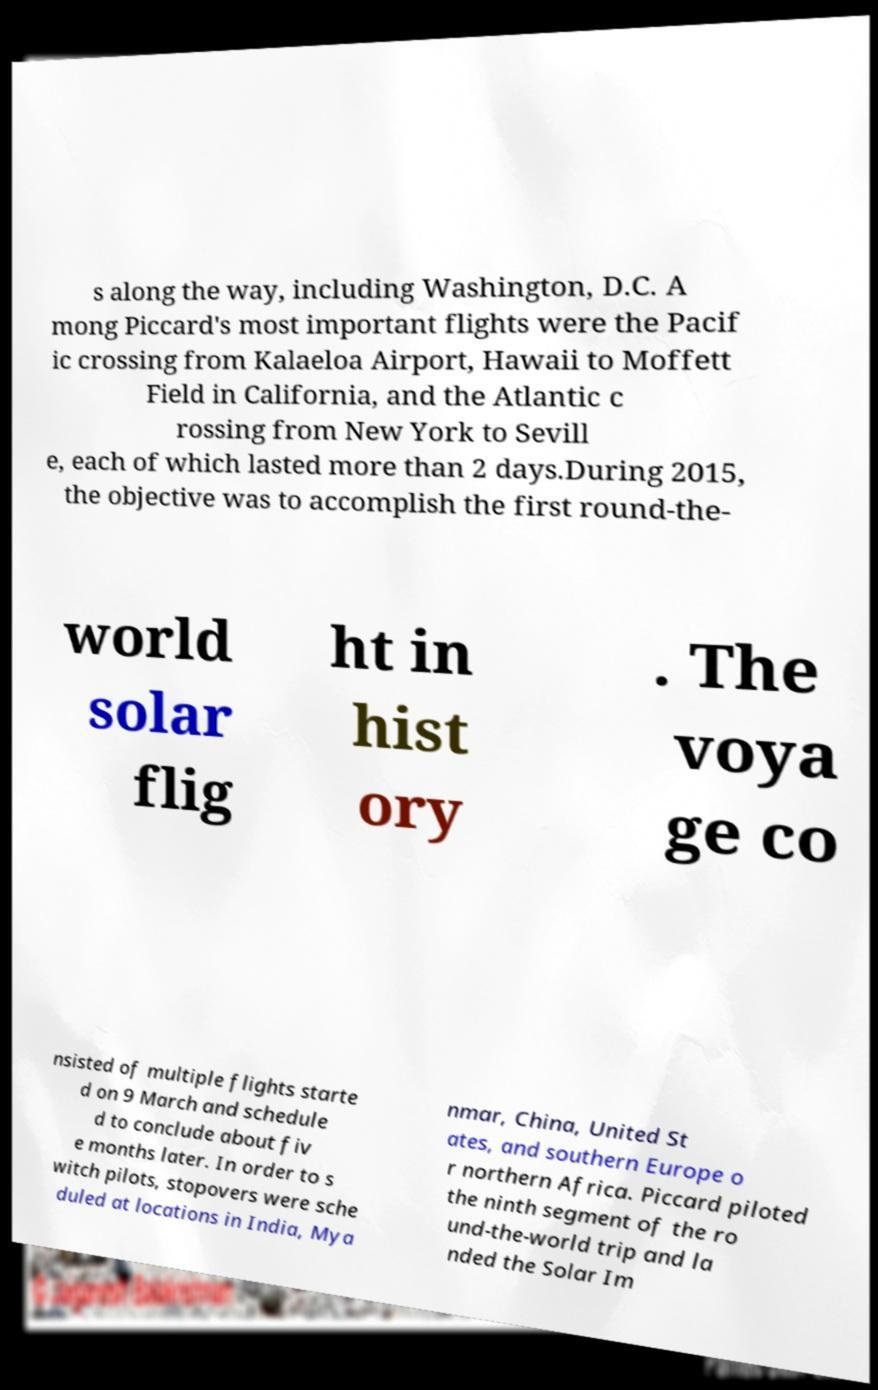Please read and relay the text visible in this image. What does it say? s along the way, including Washington, D.C. A mong Piccard's most important flights were the Pacif ic crossing from Kalaeloa Airport, Hawaii to Moffett Field in California, and the Atlantic c rossing from New York to Sevill e, each of which lasted more than 2 days.During 2015, the objective was to accomplish the first round-the- world solar flig ht in hist ory . The voya ge co nsisted of multiple flights starte d on 9 March and schedule d to conclude about fiv e months later. In order to s witch pilots, stopovers were sche duled at locations in India, Mya nmar, China, United St ates, and southern Europe o r northern Africa. Piccard piloted the ninth segment of the ro und-the-world trip and la nded the Solar Im 